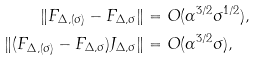<formula> <loc_0><loc_0><loc_500><loc_500>\| F _ { \Delta , ( \sigma ) } - F _ { \Delta , \sigma } \| & = O ( \alpha ^ { 3 / 2 } \sigma ^ { 1 / 2 } ) , \\ \| ( F _ { \Delta , ( \sigma ) } - F _ { \Delta , \sigma } ) J _ { \Delta , \sigma } \| & = O ( \alpha ^ { 3 / 2 } \sigma ) ,</formula> 